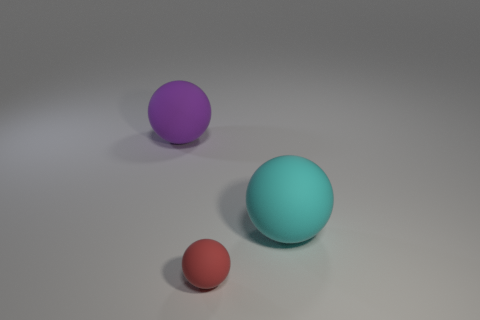What number of large matte objects are on the left side of the red rubber thing and on the right side of the small rubber ball?
Offer a very short reply. 0. The big thing right of the tiny sphere is what color?
Your response must be concise. Cyan. What size is the other cyan ball that is the same material as the small ball?
Make the answer very short. Large. There is a sphere in front of the big cyan rubber thing; what number of small rubber objects are on the left side of it?
Your answer should be compact. 0. There is a red matte ball; what number of big spheres are on the left side of it?
Give a very brief answer. 1. What color is the big thing that is on the left side of the big matte object that is right of the big thing that is on the left side of the small red matte sphere?
Offer a terse response. Purple. There is a large object on the left side of the large matte thing right of the large purple matte ball; what shape is it?
Make the answer very short. Sphere. Is there another object of the same size as the cyan thing?
Offer a terse response. Yes. How many big cyan rubber objects have the same shape as the tiny red object?
Give a very brief answer. 1. Is the number of tiny objects to the right of the tiny red matte ball the same as the number of small red rubber objects left of the big cyan rubber thing?
Offer a terse response. No. 